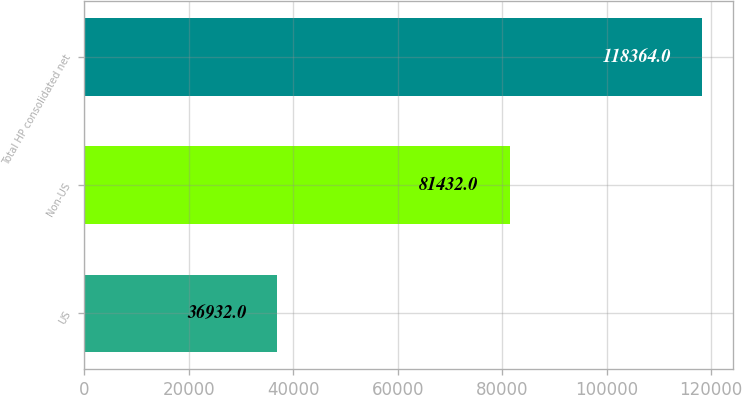Convert chart to OTSL. <chart><loc_0><loc_0><loc_500><loc_500><bar_chart><fcel>US<fcel>Non-US<fcel>Total HP consolidated net<nl><fcel>36932<fcel>81432<fcel>118364<nl></chart> 